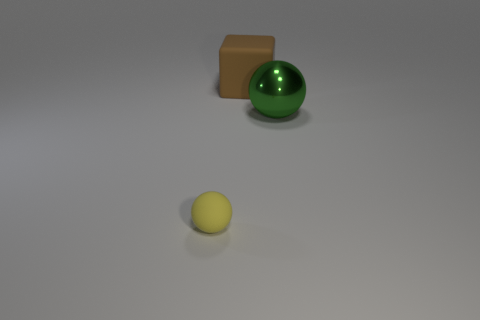Subtract all blue cubes. Subtract all brown balls. How many cubes are left? 1 Add 3 small spheres. How many objects exist? 6 Subtract all blocks. How many objects are left? 2 Add 1 big objects. How many big objects are left? 3 Add 1 brown rubber cylinders. How many brown rubber cylinders exist? 1 Subtract 0 purple balls. How many objects are left? 3 Subtract all cyan cylinders. Subtract all metallic objects. How many objects are left? 2 